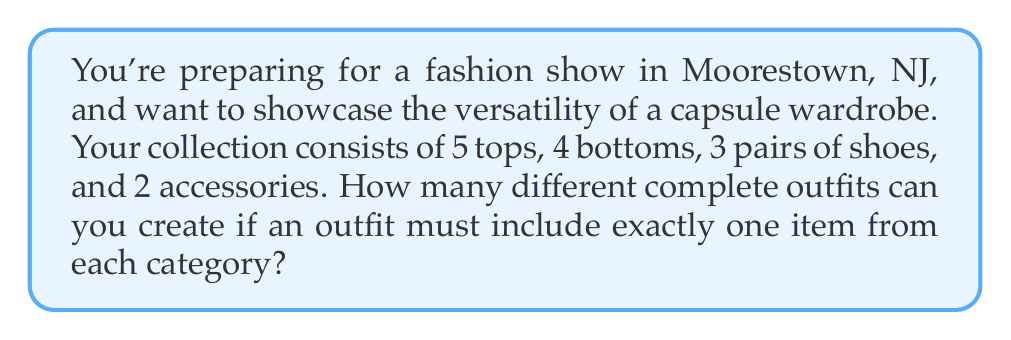What is the answer to this math problem? Let's approach this step-by-step using the multiplication principle of counting:

1) For each category, we need to choose one item:
   - 5 choices for tops
   - 4 choices for bottoms
   - 3 choices for shoes
   - 2 choices for accessories

2) According to the multiplication principle, if we have a sequence of choices where:
   - We have $m$ ways of doing something,
   - We have $n$ ways of doing another thing,
   - We have $p$ ways of doing a third thing, and so on,
   Then the total number of ways to do all these things is $m \times n \times p \times ...$

3) In this case, we multiply the number of choices for each category:

   $$ \text{Total outfits} = 5 \times 4 \times 3 \times 2 $$

4) Let's calculate:
   $$ 5 \times 4 \times 3 \times 2 = 120 $$

Therefore, you can create 120 different complete outfits from your capsule wardrobe.
Answer: 120 outfits 